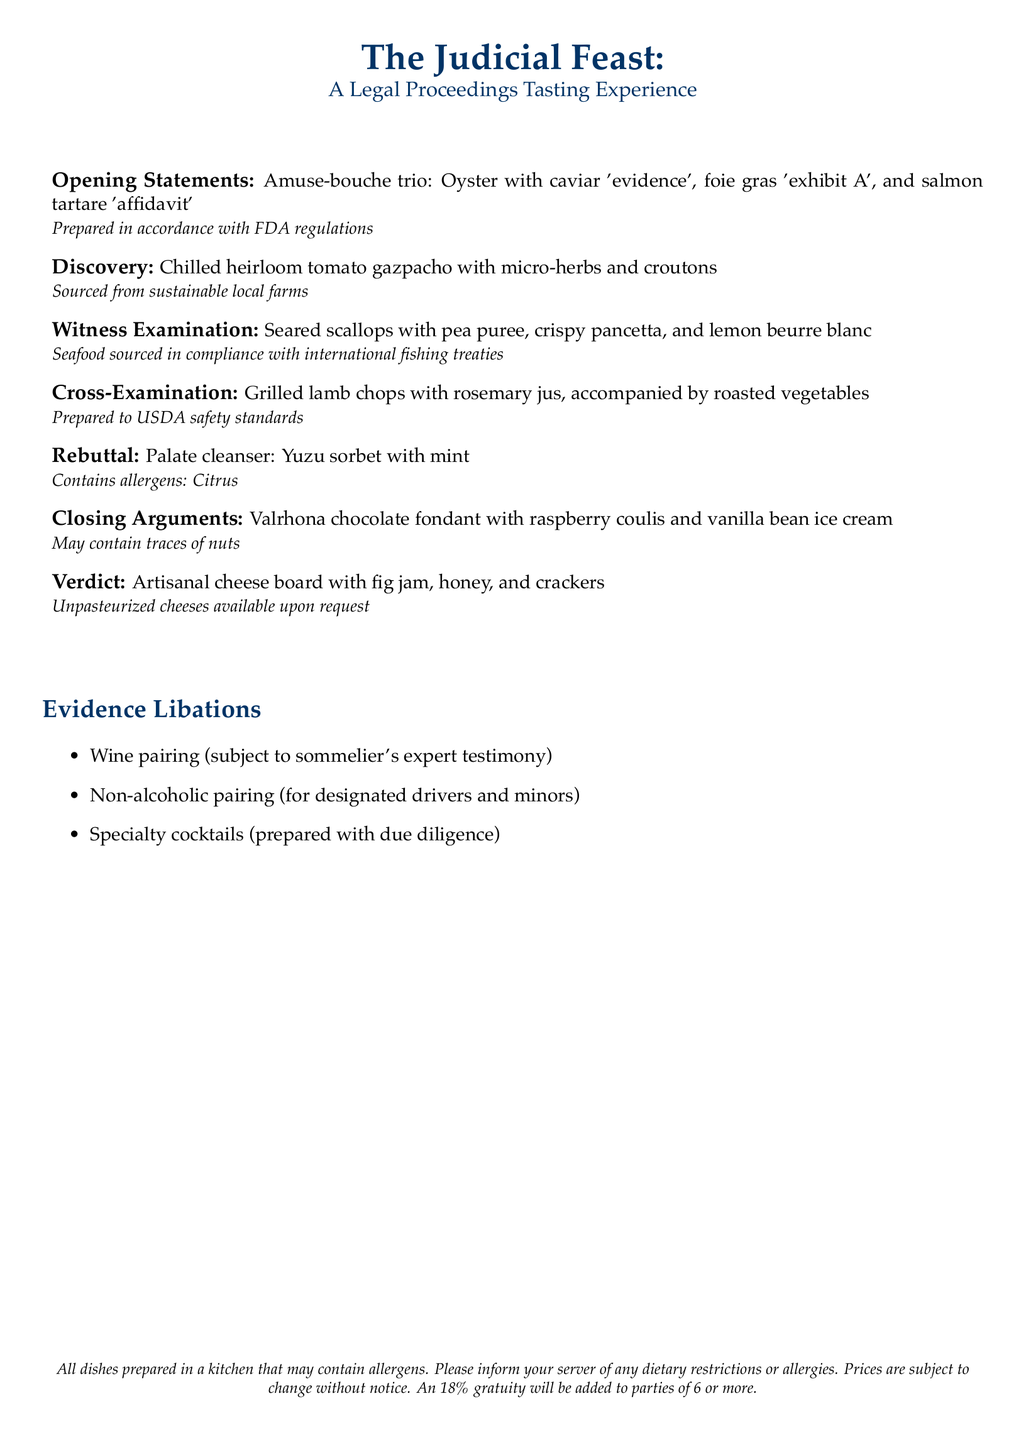What is the name of the tasting menu? The name of the tasting menu is presented at the top of the document.
Answer: The Judicial Feast How many courses are included in the tasting menu? The number of courses can be counted from the list of items in the document.
Answer: Six What is the first course called? The first course is labeled in the document under the first item.
Answer: Opening Statements What dish is served during "Witness Examination"? The dish name is specified next to the corresponding section in the menu.
Answer: Seared scallops with pea puree, crispy pancetta, and lemon beurre blanc What beverage options are mentioned under "Evidence Libations"? The options are listed in a bullet point format in the document.
Answer: Wine pairing, Non-alcoholic pairing, Specialty cocktails What allergen is present in the palate cleanser? The allergen is noted in the description of the palate cleanser dish.
Answer: Citrus What is the dessert course called? The name of the dessert course is stated in the menu.
Answer: Closing Arguments Are unpasteurized cheeses available? This information is found towards the end of the menu.
Answer: Upon request What type of dining experience does the menu represent? The type of experience is indicated in the title of the document.
Answer: Tasting experience 